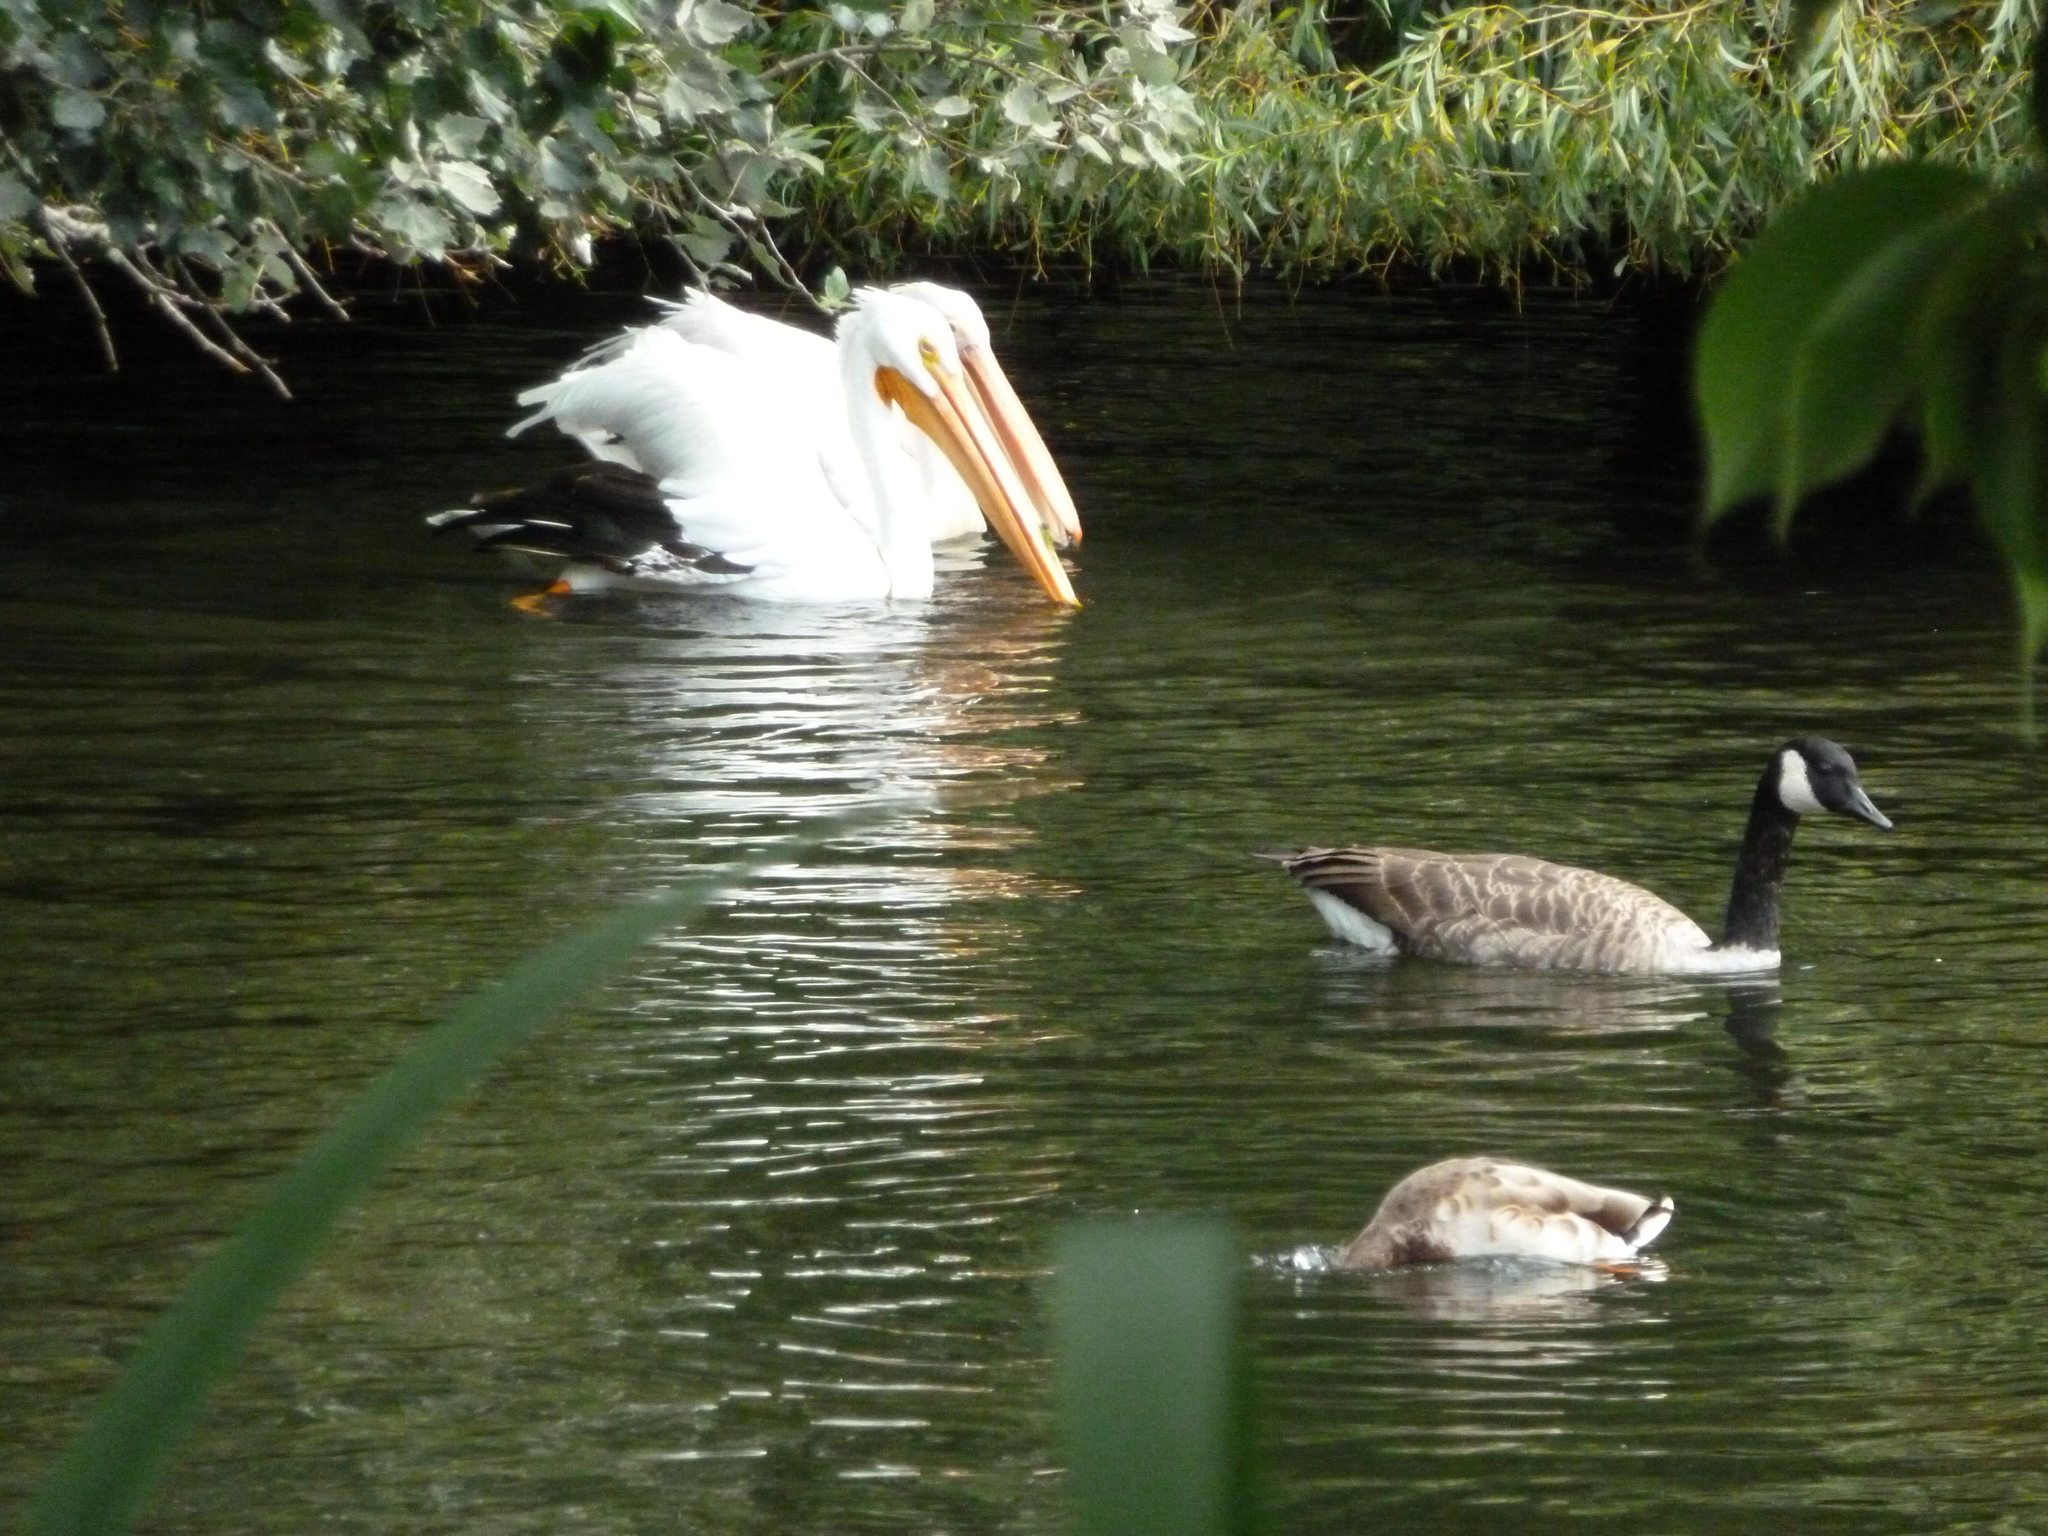What type of animals can be seen in the image? There are ducks and pelicans in the image. Where are the ducks and pelicans located? The ducks and pelicans are on the water. What can be seen in the background of the image? There are trees visible in the image. How many mice are sleeping in the sack in the image? There are no mice or sacks present in the image. 